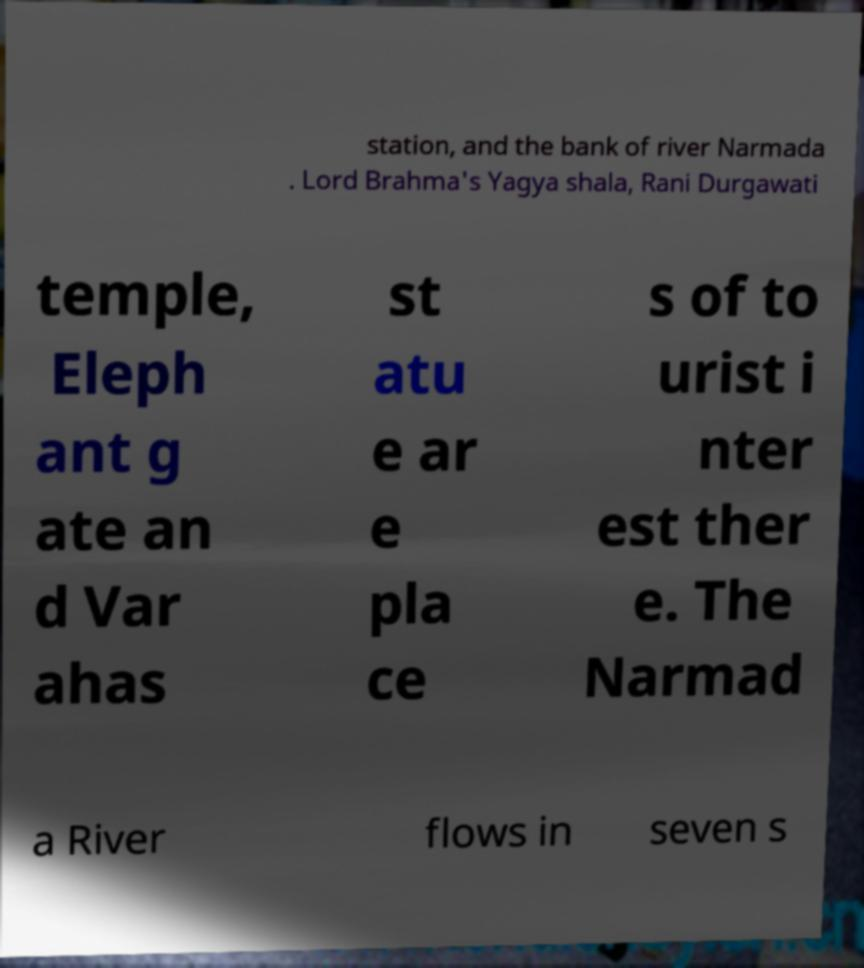Can you read and provide the text displayed in the image?This photo seems to have some interesting text. Can you extract and type it out for me? station, and the bank of river Narmada . Lord Brahma's Yagya shala, Rani Durgawati temple, Eleph ant g ate an d Var ahas st atu e ar e pla ce s of to urist i nter est ther e. The Narmad a River flows in seven s 